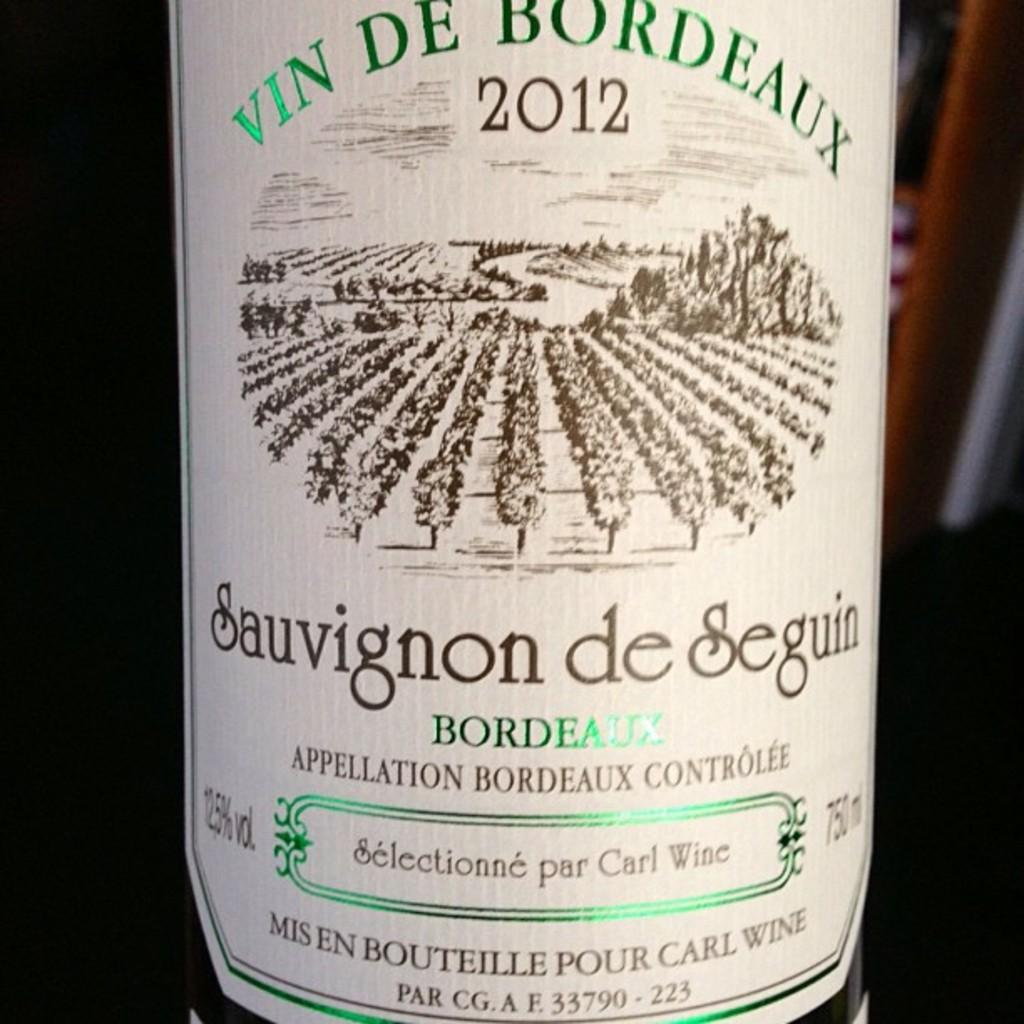<image>
Provide a brief description of the given image. The label of a bottle of Bordeaux wine from 2012. 